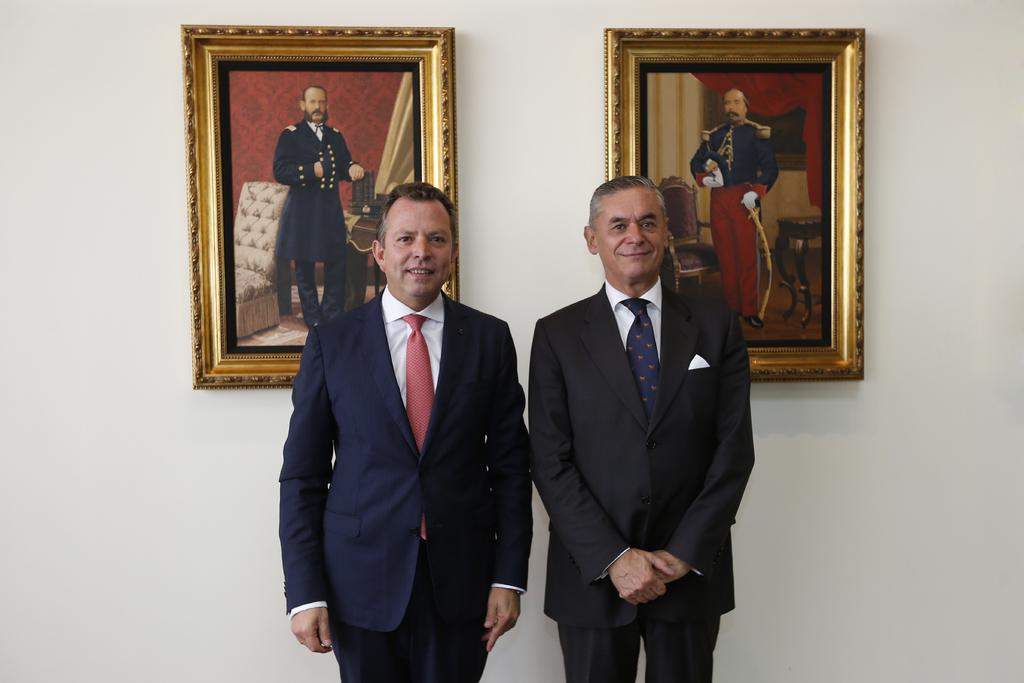How many people are in the image? There are two persons in the image. What are the persons doing in the image? The persons are standing and smiling. What can be seen in the background of the image? There are frames attached to the wall in the background of the image. How many boats are visible in the image? There are no boats present in the image. What type of goose can be seen interacting with the persons in the image? There is no goose present in the image; the persons are standing and smiling without any interaction with a goose. 